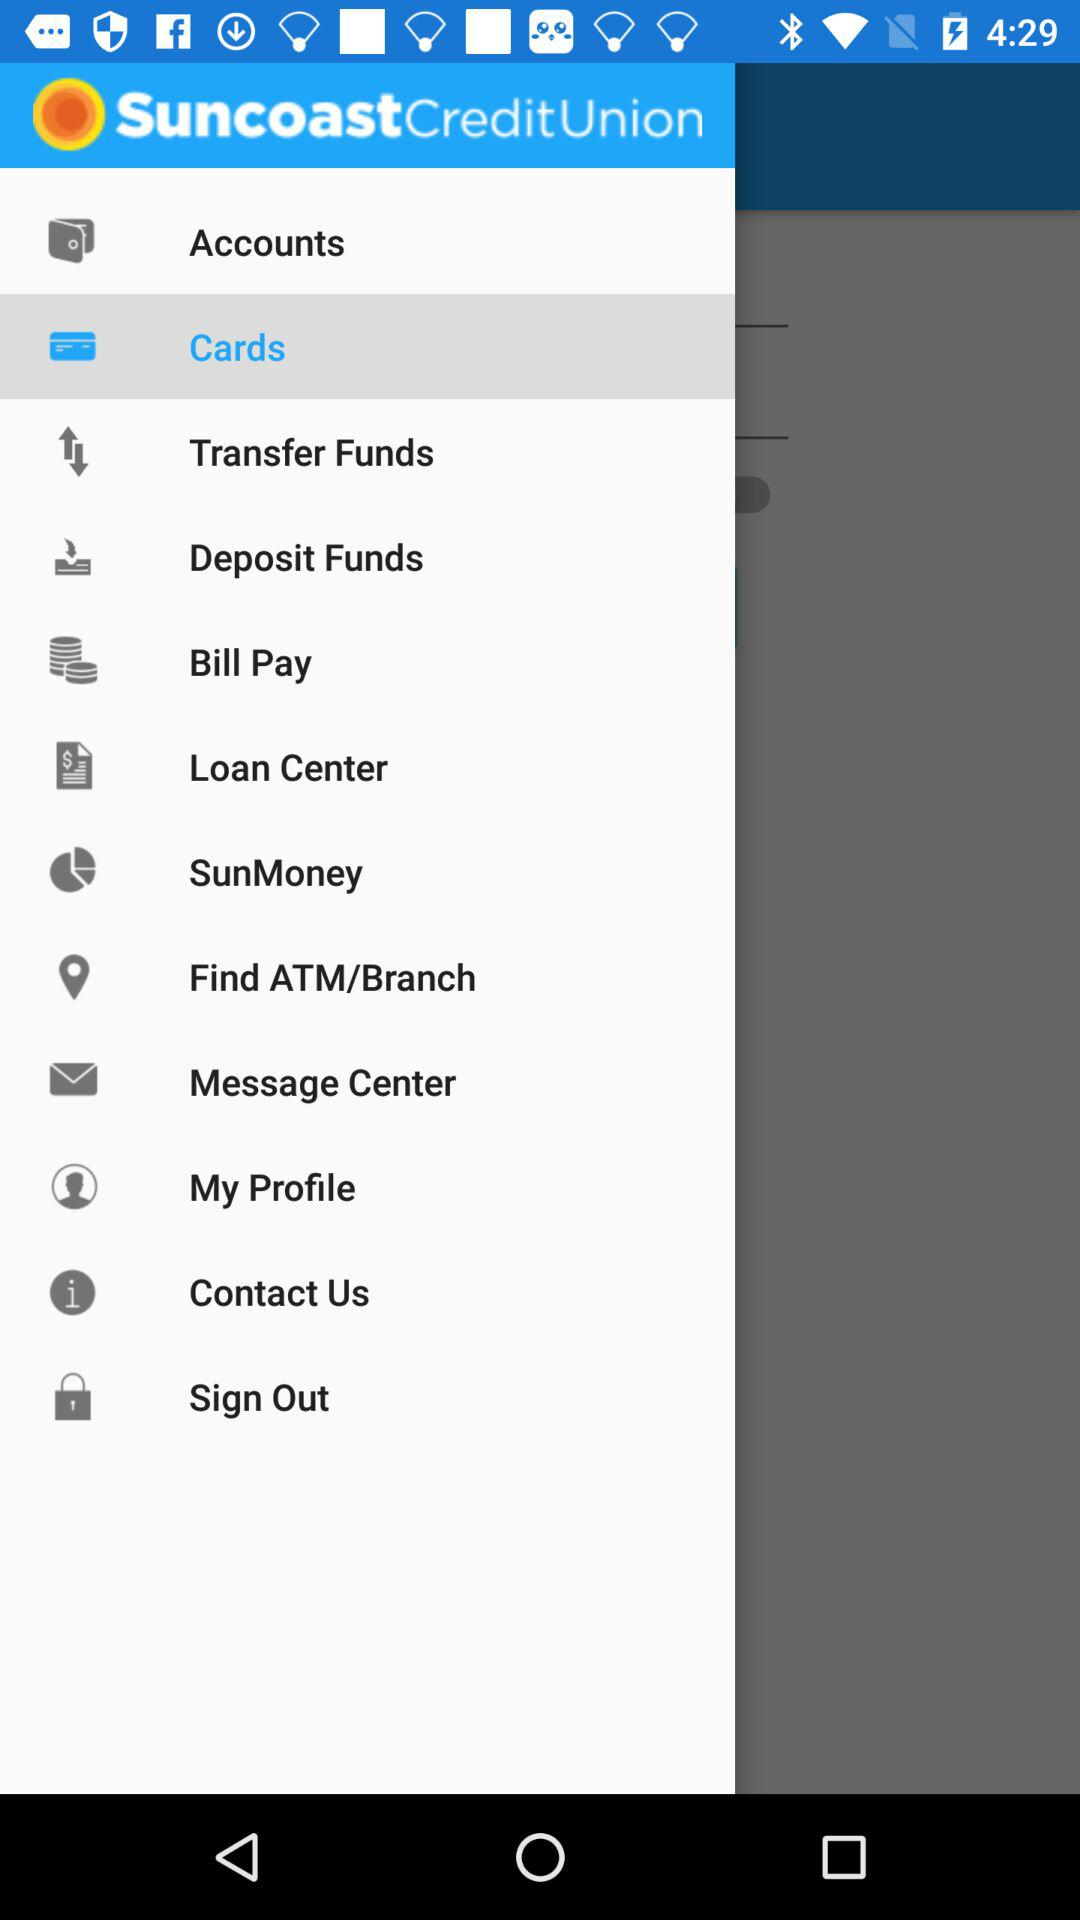How many messages are in "Message Center"?
When the provided information is insufficient, respond with <no answer>. <no answer> 